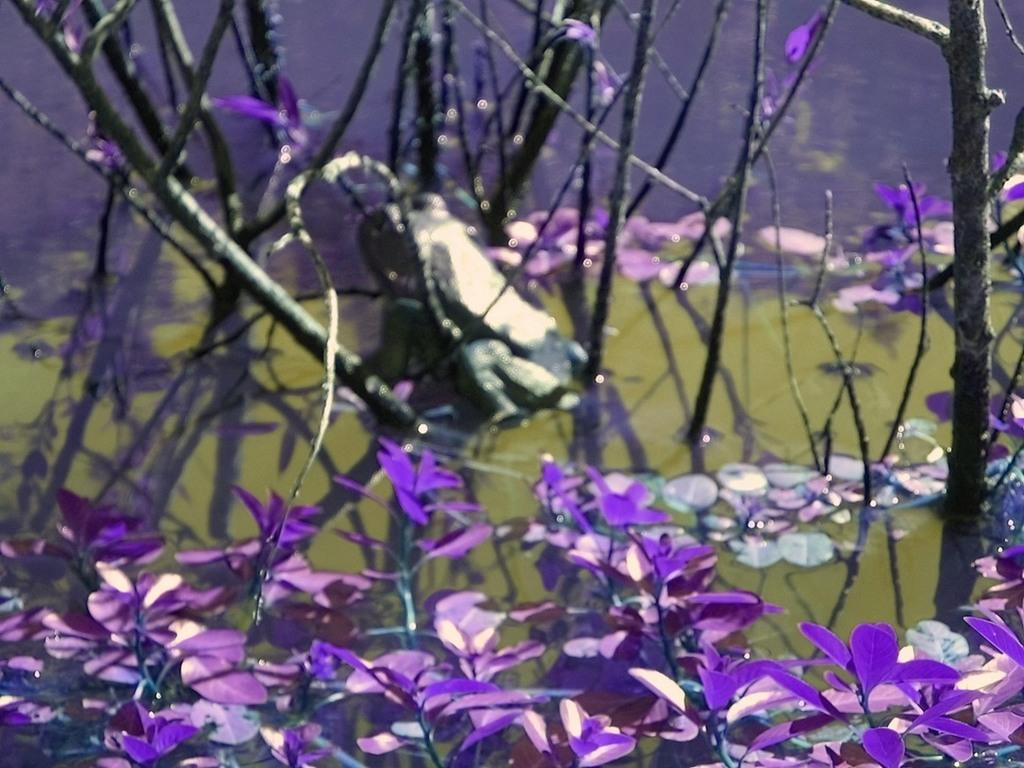What type of vegetation is featured in the image? There are leaves in the image. What color are the leaves? The leaves are purple in color. What can be seen in the middle of the image? There appears to be an object in the middle of the image. What is visible at the back side of the image? There is water visible at the back side of the image. What brand of toothpaste is being advertised in the image? There is no toothpaste or advertisement present in the image. How many family members can be seen in the image? There is no family or family members present in the image. 